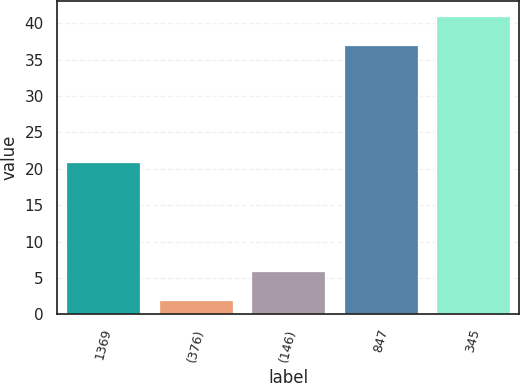<chart> <loc_0><loc_0><loc_500><loc_500><bar_chart><fcel>1369<fcel>(376)<fcel>(146)<fcel>847<fcel>345<nl><fcel>21<fcel>2<fcel>5.9<fcel>37<fcel>41<nl></chart> 